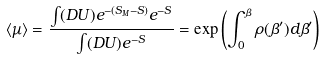Convert formula to latex. <formula><loc_0><loc_0><loc_500><loc_500>\langle \mu \rangle = \frac { \int ( D U ) e ^ { - ( S _ { M } - S ) } e ^ { - S } } { \int ( D U ) e ^ { - S } } = \exp \left ( \int _ { 0 } ^ { \beta } \rho ( \beta ^ { \prime } ) d \beta ^ { \prime } \right )</formula> 